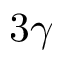Convert formula to latex. <formula><loc_0><loc_0><loc_500><loc_500>3 \gamma</formula> 